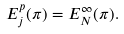<formula> <loc_0><loc_0><loc_500><loc_500>E _ { j } ^ { p } ( \pi ) = E _ { N } ^ { \infty } ( \pi ) .</formula> 